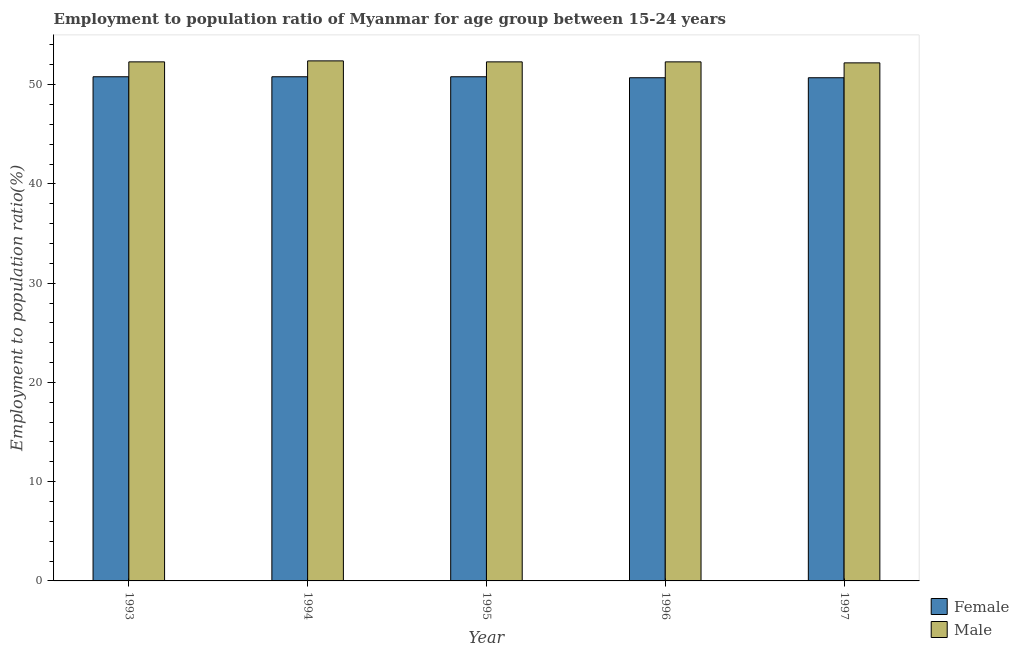How many different coloured bars are there?
Your response must be concise. 2. How many groups of bars are there?
Your answer should be compact. 5. Are the number of bars on each tick of the X-axis equal?
Ensure brevity in your answer.  Yes. How many bars are there on the 1st tick from the left?
Offer a very short reply. 2. How many bars are there on the 5th tick from the right?
Provide a short and direct response. 2. What is the employment to population ratio(male) in 1996?
Give a very brief answer. 52.3. Across all years, what is the maximum employment to population ratio(female)?
Provide a succinct answer. 50.8. Across all years, what is the minimum employment to population ratio(female)?
Your answer should be very brief. 50.7. In which year was the employment to population ratio(female) maximum?
Provide a succinct answer. 1993. What is the total employment to population ratio(female) in the graph?
Make the answer very short. 253.8. What is the difference between the employment to population ratio(male) in 1996 and that in 1997?
Your response must be concise. 0.1. What is the difference between the employment to population ratio(male) in 1994 and the employment to population ratio(female) in 1996?
Ensure brevity in your answer.  0.1. What is the average employment to population ratio(male) per year?
Offer a terse response. 52.3. In the year 1993, what is the difference between the employment to population ratio(male) and employment to population ratio(female)?
Your answer should be compact. 0. In how many years, is the employment to population ratio(female) greater than 28 %?
Offer a terse response. 5. What is the ratio of the employment to population ratio(female) in 1996 to that in 1997?
Provide a short and direct response. 1. Is the employment to population ratio(female) in 1995 less than that in 1996?
Offer a very short reply. No. What is the difference between the highest and the second highest employment to population ratio(male)?
Keep it short and to the point. 0.1. What is the difference between the highest and the lowest employment to population ratio(male)?
Offer a very short reply. 0.2. What does the 1st bar from the left in 1993 represents?
Your response must be concise. Female. What does the 2nd bar from the right in 1994 represents?
Make the answer very short. Female. Does the graph contain grids?
Ensure brevity in your answer.  No. How are the legend labels stacked?
Provide a short and direct response. Vertical. What is the title of the graph?
Ensure brevity in your answer.  Employment to population ratio of Myanmar for age group between 15-24 years. What is the label or title of the Y-axis?
Your answer should be compact. Employment to population ratio(%). What is the Employment to population ratio(%) in Female in 1993?
Offer a terse response. 50.8. What is the Employment to population ratio(%) in Male in 1993?
Your answer should be compact. 52.3. What is the Employment to population ratio(%) of Female in 1994?
Offer a terse response. 50.8. What is the Employment to population ratio(%) in Male in 1994?
Give a very brief answer. 52.4. What is the Employment to population ratio(%) of Female in 1995?
Offer a very short reply. 50.8. What is the Employment to population ratio(%) in Male in 1995?
Offer a terse response. 52.3. What is the Employment to population ratio(%) in Female in 1996?
Give a very brief answer. 50.7. What is the Employment to population ratio(%) in Male in 1996?
Provide a short and direct response. 52.3. What is the Employment to population ratio(%) in Female in 1997?
Your response must be concise. 50.7. What is the Employment to population ratio(%) in Male in 1997?
Your answer should be very brief. 52.2. Across all years, what is the maximum Employment to population ratio(%) of Female?
Your answer should be very brief. 50.8. Across all years, what is the maximum Employment to population ratio(%) in Male?
Make the answer very short. 52.4. Across all years, what is the minimum Employment to population ratio(%) of Female?
Keep it short and to the point. 50.7. Across all years, what is the minimum Employment to population ratio(%) of Male?
Ensure brevity in your answer.  52.2. What is the total Employment to population ratio(%) of Female in the graph?
Your response must be concise. 253.8. What is the total Employment to population ratio(%) in Male in the graph?
Offer a terse response. 261.5. What is the difference between the Employment to population ratio(%) of Female in 1993 and that in 1994?
Offer a terse response. 0. What is the difference between the Employment to population ratio(%) of Male in 1993 and that in 1994?
Your answer should be compact. -0.1. What is the difference between the Employment to population ratio(%) of Female in 1993 and that in 1995?
Offer a very short reply. 0. What is the difference between the Employment to population ratio(%) of Male in 1993 and that in 1995?
Give a very brief answer. 0. What is the difference between the Employment to population ratio(%) of Female in 1993 and that in 1996?
Offer a very short reply. 0.1. What is the difference between the Employment to population ratio(%) of Male in 1993 and that in 1996?
Give a very brief answer. 0. What is the difference between the Employment to population ratio(%) of Female in 1993 and that in 1997?
Your answer should be very brief. 0.1. What is the difference between the Employment to population ratio(%) of Male in 1993 and that in 1997?
Offer a very short reply. 0.1. What is the difference between the Employment to population ratio(%) of Male in 1994 and that in 1996?
Give a very brief answer. 0.1. What is the difference between the Employment to population ratio(%) of Male in 1994 and that in 1997?
Your answer should be very brief. 0.2. What is the difference between the Employment to population ratio(%) of Male in 1995 and that in 1996?
Ensure brevity in your answer.  0. What is the difference between the Employment to population ratio(%) in Female in 1995 and that in 1997?
Your answer should be compact. 0.1. What is the difference between the Employment to population ratio(%) of Female in 1996 and that in 1997?
Your answer should be compact. 0. What is the difference between the Employment to population ratio(%) of Male in 1996 and that in 1997?
Your answer should be very brief. 0.1. What is the difference between the Employment to population ratio(%) of Female in 1993 and the Employment to population ratio(%) of Male in 1995?
Offer a very short reply. -1.5. What is the difference between the Employment to population ratio(%) in Female in 1994 and the Employment to population ratio(%) in Male in 1995?
Give a very brief answer. -1.5. What is the difference between the Employment to population ratio(%) in Female in 1994 and the Employment to population ratio(%) in Male in 1996?
Your answer should be very brief. -1.5. What is the difference between the Employment to population ratio(%) of Female in 1995 and the Employment to population ratio(%) of Male in 1997?
Ensure brevity in your answer.  -1.4. What is the difference between the Employment to population ratio(%) of Female in 1996 and the Employment to population ratio(%) of Male in 1997?
Offer a very short reply. -1.5. What is the average Employment to population ratio(%) of Female per year?
Ensure brevity in your answer.  50.76. What is the average Employment to population ratio(%) in Male per year?
Provide a short and direct response. 52.3. What is the ratio of the Employment to population ratio(%) of Female in 1993 to that in 1994?
Offer a terse response. 1. What is the ratio of the Employment to population ratio(%) in Male in 1993 to that in 1994?
Your answer should be very brief. 1. What is the ratio of the Employment to population ratio(%) in Male in 1993 to that in 1995?
Provide a short and direct response. 1. What is the ratio of the Employment to population ratio(%) of Male in 1993 to that in 1996?
Your answer should be compact. 1. What is the ratio of the Employment to population ratio(%) of Female in 1993 to that in 1997?
Your answer should be compact. 1. What is the ratio of the Employment to population ratio(%) in Female in 1994 to that in 1995?
Your response must be concise. 1. What is the ratio of the Employment to population ratio(%) in Male in 1994 to that in 1997?
Offer a terse response. 1. What is the difference between the highest and the lowest Employment to population ratio(%) of Female?
Your answer should be compact. 0.1. 